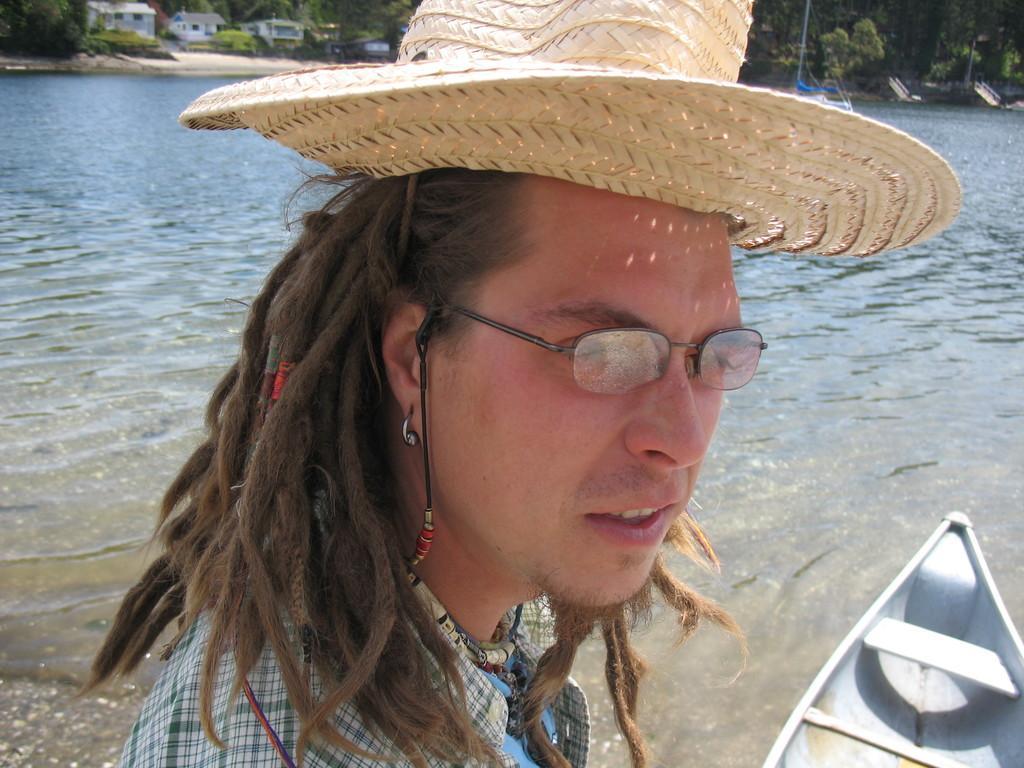Describe this image in one or two sentences. In this image we can see a person wearing hat and specs. And we can see boat on the water. In the background there are trees and buildings. 